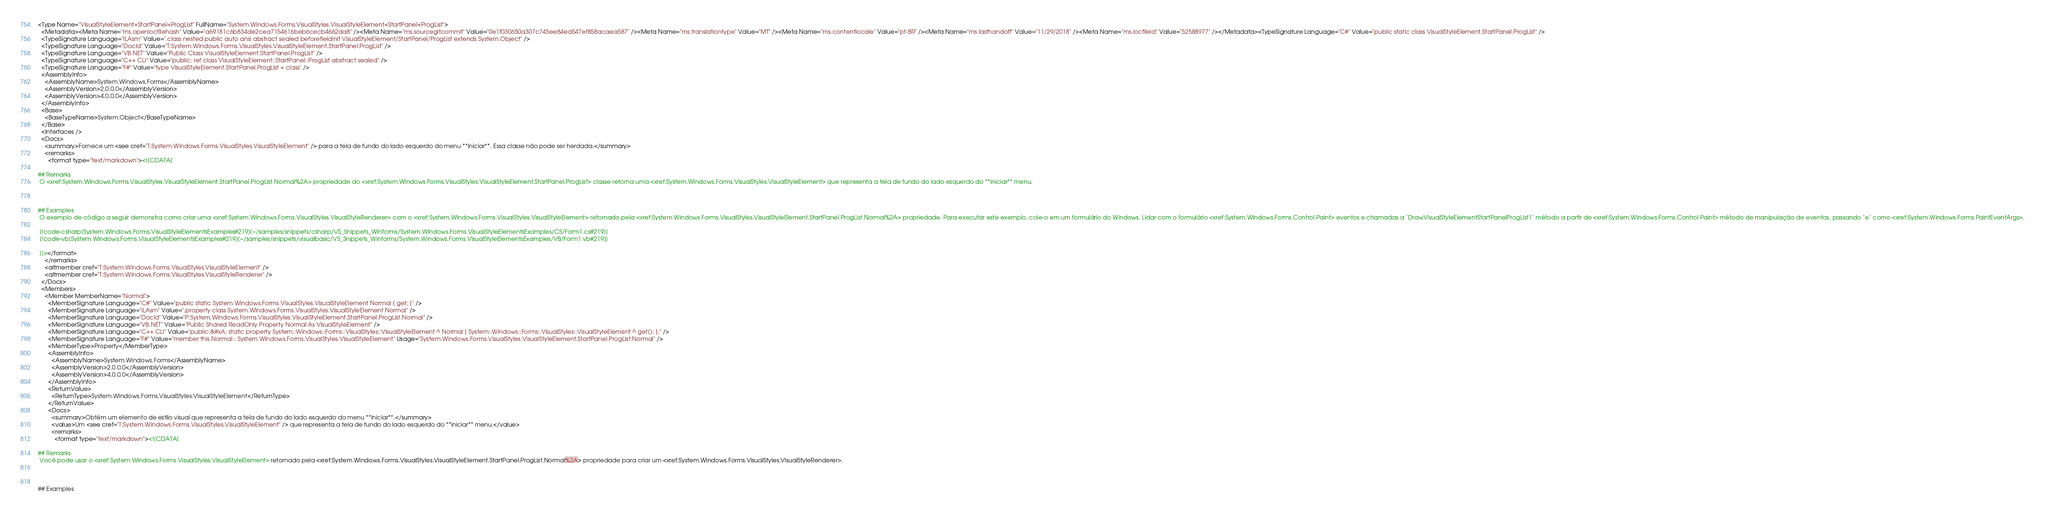<code> <loc_0><loc_0><loc_500><loc_500><_XML_><Type Name="VisualStyleElement+StartPanel+ProgList" FullName="System.Windows.Forms.VisualStyles.VisualStyleElement+StartPanel+ProgList">
  <Metadata><Meta Name="ms.openlocfilehash" Value="a69181c6b834de2cea7154616beb6cecb4662da8" /><Meta Name="ms.sourcegitcommit" Value="0e1f030650a307c745ee84ed547ef858acaea587" /><Meta Name="ms.translationtype" Value="MT" /><Meta Name="ms.contentlocale" Value="pt-BR" /><Meta Name="ms.lasthandoff" Value="11/29/2018" /><Meta Name="ms.locfileid" Value="52588977" /></Metadata><TypeSignature Language="C#" Value="public static class VisualStyleElement.StartPanel.ProgList" />
  <TypeSignature Language="ILAsm" Value=".class nested public auto ansi abstract sealed beforefieldinit VisualStyleElement/StartPanel/ProgList extends System.Object" />
  <TypeSignature Language="DocId" Value="T:System.Windows.Forms.VisualStyles.VisualStyleElement.StartPanel.ProgList" />
  <TypeSignature Language="VB.NET" Value="Public Class VisualStyleElement.StartPanel.ProgList" />
  <TypeSignature Language="C++ CLI" Value="public: ref class VisualStyleElement::StartPanel::ProgList abstract sealed" />
  <TypeSignature Language="F#" Value="type VisualStyleElement.StartPanel.ProgList = class" />
  <AssemblyInfo>
    <AssemblyName>System.Windows.Forms</AssemblyName>
    <AssemblyVersion>2.0.0.0</AssemblyVersion>
    <AssemblyVersion>4.0.0.0</AssemblyVersion>
  </AssemblyInfo>
  <Base>
    <BaseTypeName>System.Object</BaseTypeName>
  </Base>
  <Interfaces />
  <Docs>
    <summary>Fornece um <see cref="T:System.Windows.Forms.VisualStyles.VisualStyleElement" /> para a tela de fundo do lado esquerdo do menu **Iniciar**. Essa classe não pode ser herdada.</summary>
    <remarks>
      <format type="text/markdown"><![CDATA[  
  
## Remarks  
 O <xref:System.Windows.Forms.VisualStyles.VisualStyleElement.StartPanel.ProgList.Normal%2A> propriedade do <xref:System.Windows.Forms.VisualStyles.VisualStyleElement.StartPanel.ProgList> classe retorna uma <xref:System.Windows.Forms.VisualStyles.VisualStyleElement> que representa a tela de fundo do lado esquerdo do **iniciar** menu.  
  
   
  
## Examples  
 O exemplo de código a seguir demonstra como criar uma <xref:System.Windows.Forms.VisualStyles.VisualStyleRenderer> com o <xref:System.Windows.Forms.VisualStyles.VisualStyleElement> retornado pela <xref:System.Windows.Forms.VisualStyles.VisualStyleElement.StartPanel.ProgList.Normal%2A> propriedade. Para executar este exemplo, cole-o em um formulário do Windows. Lidar com o formulário <xref:System.Windows.Forms.Control.Paint> eventos e chamadas a `DrawVisualStyleElementStartPanelProgList1` método a partir de <xref:System.Windows.Forms.Control.Paint> método de manipulação de eventos, passando `e` como <xref:System.Windows.Forms.PaintEventArgs>.  
  
 [!code-csharp[System.Windows.Forms.VisualStyleElementsExamples#219](~/samples/snippets/csharp/VS_Snippets_Winforms/System.Windows.Forms.VisualStyleElementsExamples/CS/Form1.cs#219)]
 [!code-vb[System.Windows.Forms.VisualStyleElementsExamples#219](~/samples/snippets/visualbasic/VS_Snippets_Winforms/System.Windows.Forms.VisualStyleElementsExamples/VB/Form1.vb#219)]  
  
 ]]></format>
    </remarks>
    <altmember cref="T:System.Windows.Forms.VisualStyles.VisualStyleElement" />
    <altmember cref="T:System.Windows.Forms.VisualStyles.VisualStyleRenderer" />
  </Docs>
  <Members>
    <Member MemberName="Normal">
      <MemberSignature Language="C#" Value="public static System.Windows.Forms.VisualStyles.VisualStyleElement Normal { get; }" />
      <MemberSignature Language="ILAsm" Value=".property class System.Windows.Forms.VisualStyles.VisualStyleElement Normal" />
      <MemberSignature Language="DocId" Value="P:System.Windows.Forms.VisualStyles.VisualStyleElement.StartPanel.ProgList.Normal" />
      <MemberSignature Language="VB.NET" Value="Public Shared ReadOnly Property Normal As VisualStyleElement" />
      <MemberSignature Language="C++ CLI" Value="public:&#xA; static property System::Windows::Forms::VisualStyles::VisualStyleElement ^ Normal { System::Windows::Forms::VisualStyles::VisualStyleElement ^ get(); };" />
      <MemberSignature Language="F#" Value="member this.Normal : System.Windows.Forms.VisualStyles.VisualStyleElement" Usage="System.Windows.Forms.VisualStyles.VisualStyleElement.StartPanel.ProgList.Normal" />
      <MemberType>Property</MemberType>
      <AssemblyInfo>
        <AssemblyName>System.Windows.Forms</AssemblyName>
        <AssemblyVersion>2.0.0.0</AssemblyVersion>
        <AssemblyVersion>4.0.0.0</AssemblyVersion>
      </AssemblyInfo>
      <ReturnValue>
        <ReturnType>System.Windows.Forms.VisualStyles.VisualStyleElement</ReturnType>
      </ReturnValue>
      <Docs>
        <summary>Obtém um elemento de estilo visual que representa a tela de fundo do lado esquerdo do menu **Iniciar**.</summary>
        <value>Um <see cref="T:System.Windows.Forms.VisualStyles.VisualStyleElement" /> que representa a tela de fundo do lado esquerdo do **iniciar** menu.</value>
        <remarks>
          <format type="text/markdown"><![CDATA[  
  
## Remarks  
 Você pode usar o <xref:System.Windows.Forms.VisualStyles.VisualStyleElement> retornado pela <xref:System.Windows.Forms.VisualStyles.VisualStyleElement.StartPanel.ProgList.Normal%2A> propriedade para criar um <xref:System.Windows.Forms.VisualStyles.VisualStyleRenderer>.  
  
   
  
## Examples  </code> 